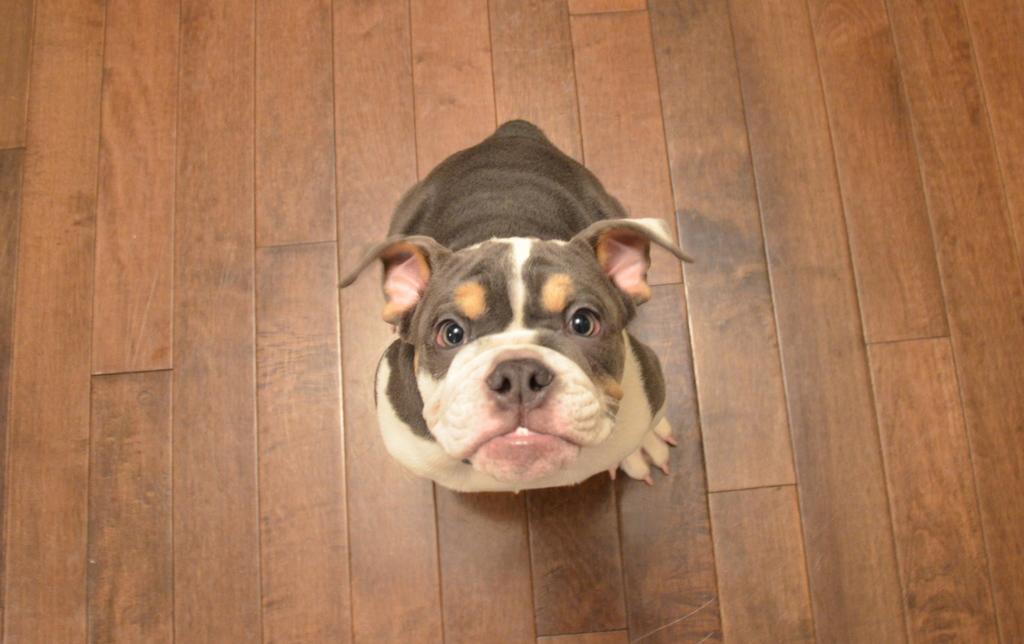In one or two sentences, can you explain what this image depicts? In the center of the image we can see a bulldog. In the background of the image we can see the floor. 